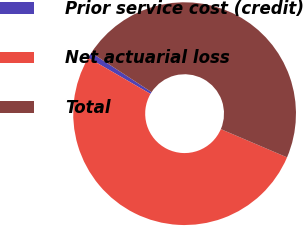Convert chart. <chart><loc_0><loc_0><loc_500><loc_500><pie_chart><fcel>Prior service cost (credit)<fcel>Net actuarial loss<fcel>Total<nl><fcel>0.84%<fcel>51.94%<fcel>47.22%<nl></chart> 